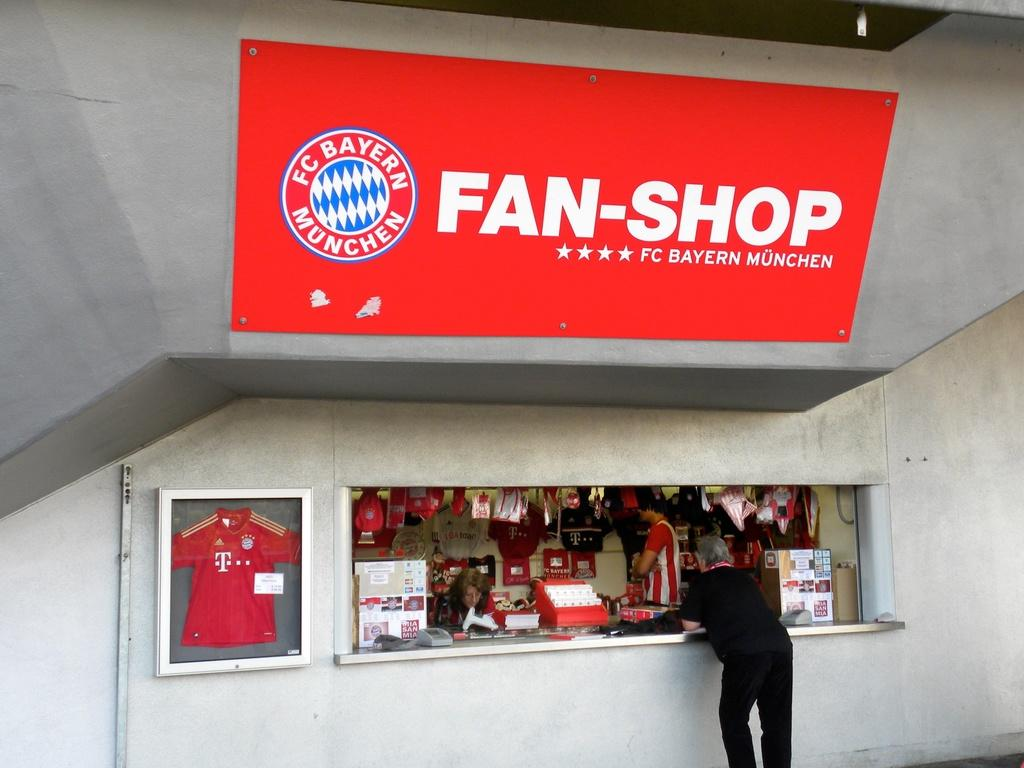<image>
Offer a succinct explanation of the picture presented. A red Fan-Shop sign above a window offering goods. 